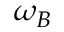<formula> <loc_0><loc_0><loc_500><loc_500>\omega _ { B }</formula> 